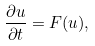Convert formula to latex. <formula><loc_0><loc_0><loc_500><loc_500>\frac { \partial u } { \partial t } = F ( u ) ,</formula> 